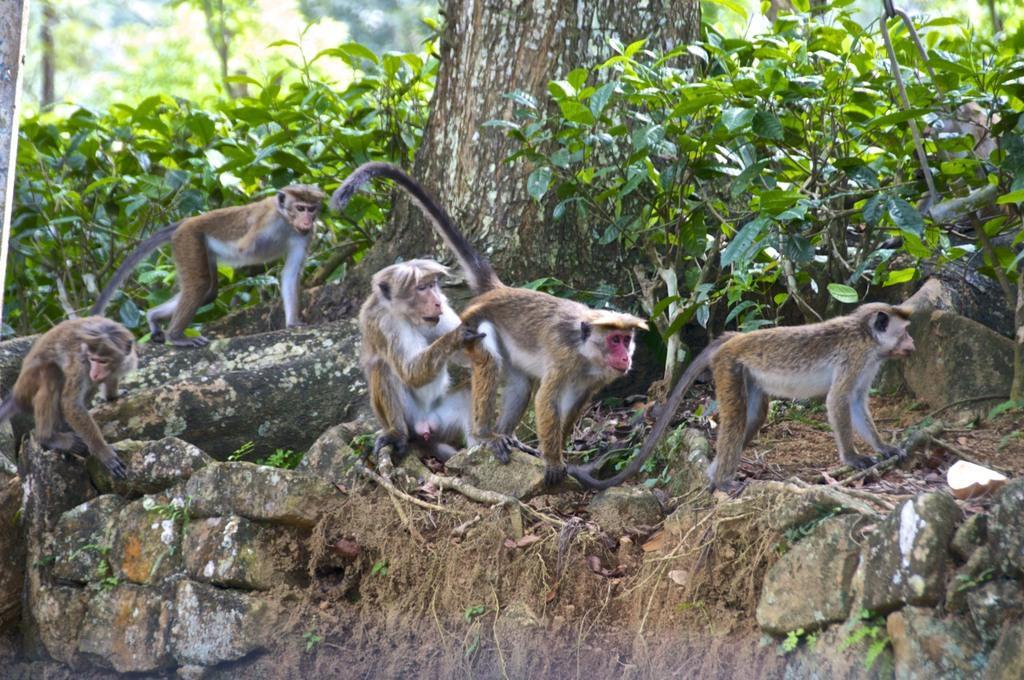Could you give a brief overview of what you see in this image? In this image we can see some monkeys on the rocks, there are plants, trees, and the background is blurred. 